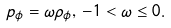Convert formula to latex. <formula><loc_0><loc_0><loc_500><loc_500>p _ { \phi } = \omega \rho _ { \phi } , \, - 1 < \omega \leq 0 .</formula> 